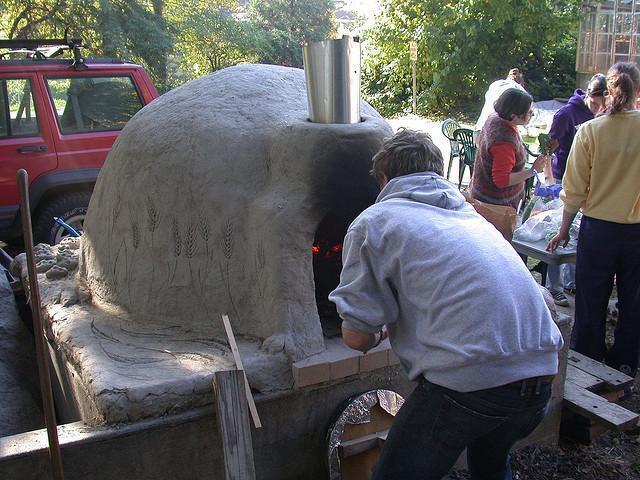In what location was this oven built?
Make your selection from the four choices given to correctly answer the question.
Options: Here, mexican factory, mall, farm. Here. 